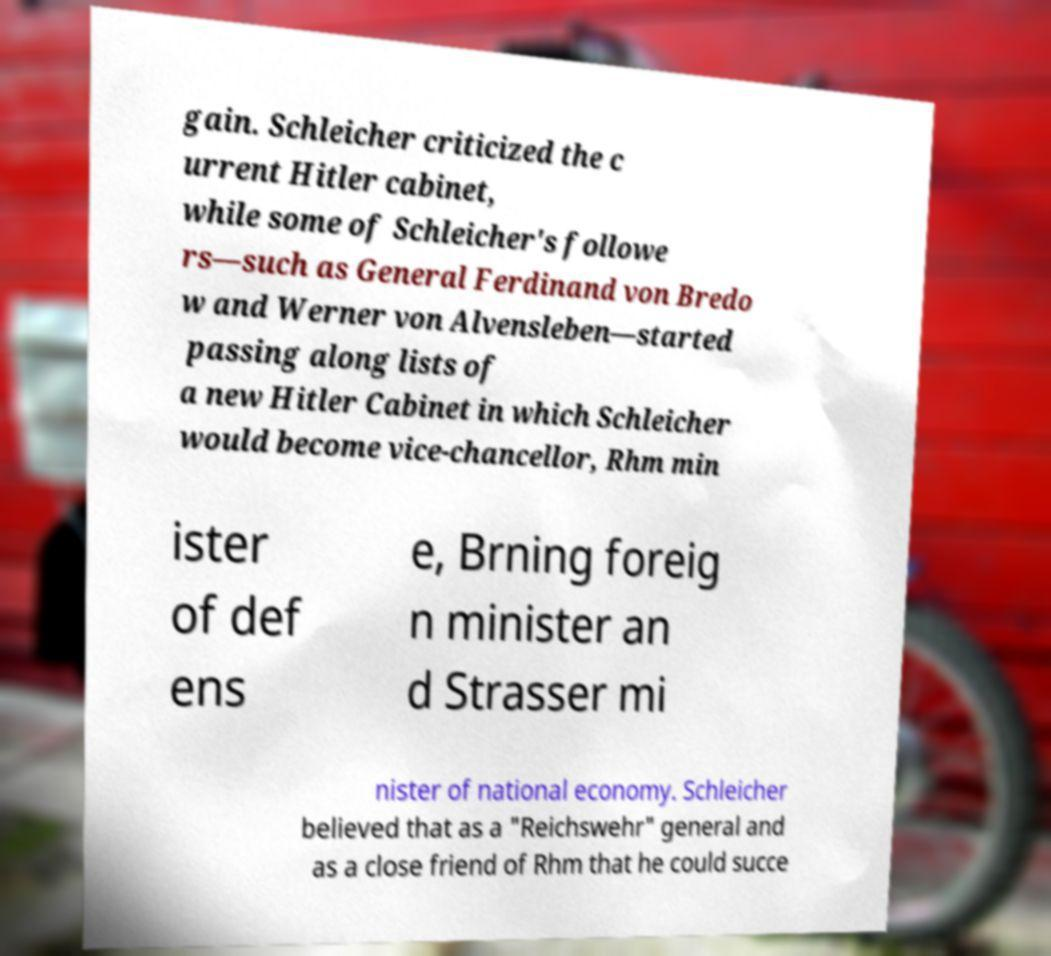What messages or text are displayed in this image? I need them in a readable, typed format. gain. Schleicher criticized the c urrent Hitler cabinet, while some of Schleicher's followe rs—such as General Ferdinand von Bredo w and Werner von Alvensleben—started passing along lists of a new Hitler Cabinet in which Schleicher would become vice-chancellor, Rhm min ister of def ens e, Brning foreig n minister an d Strasser mi nister of national economy. Schleicher believed that as a "Reichswehr" general and as a close friend of Rhm that he could succe 